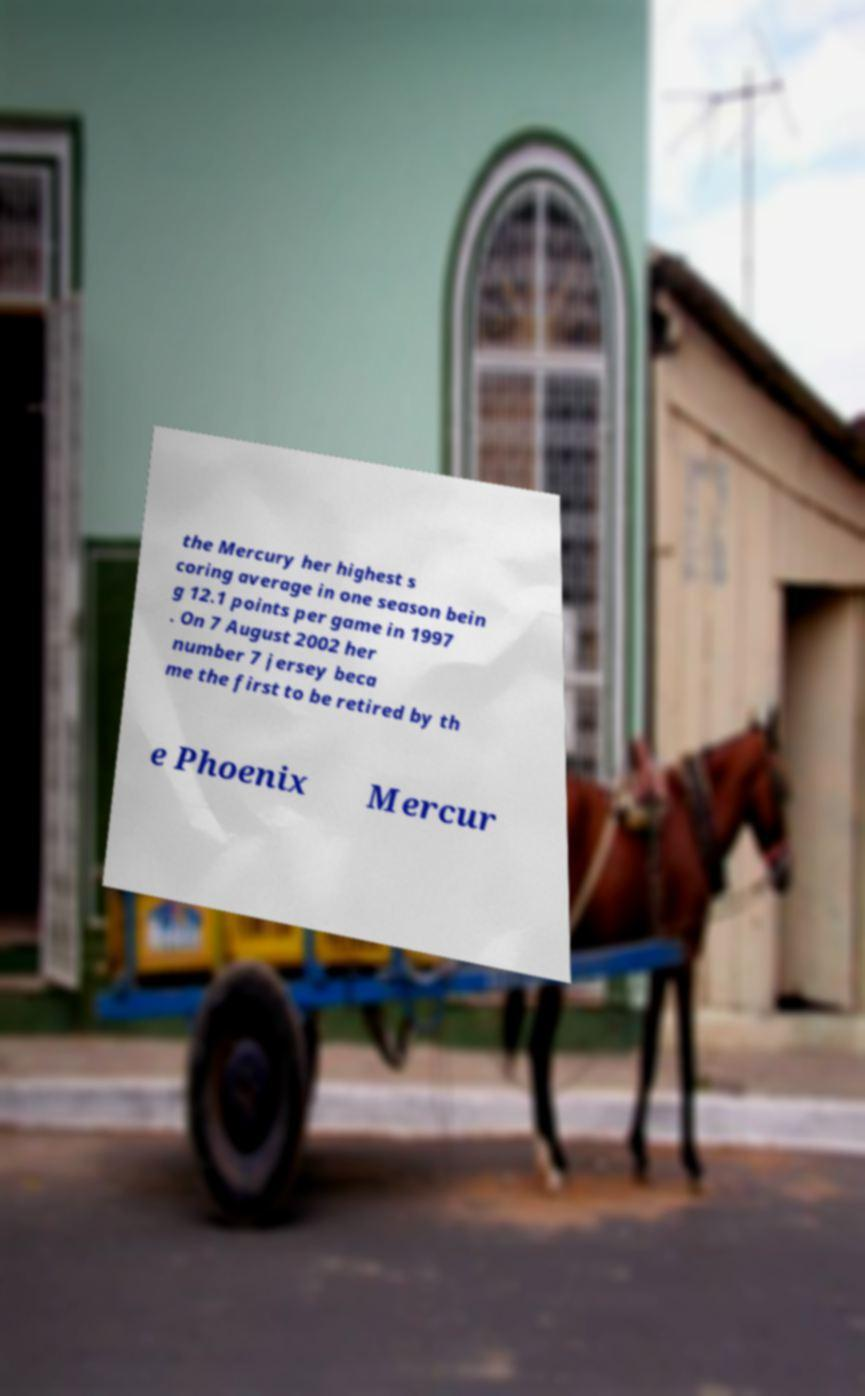For documentation purposes, I need the text within this image transcribed. Could you provide that? the Mercury her highest s coring average in one season bein g 12.1 points per game in 1997 . On 7 August 2002 her number 7 jersey beca me the first to be retired by th e Phoenix Mercur 